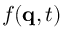Convert formula to latex. <formula><loc_0><loc_0><loc_500><loc_500>f ( q , t )</formula> 